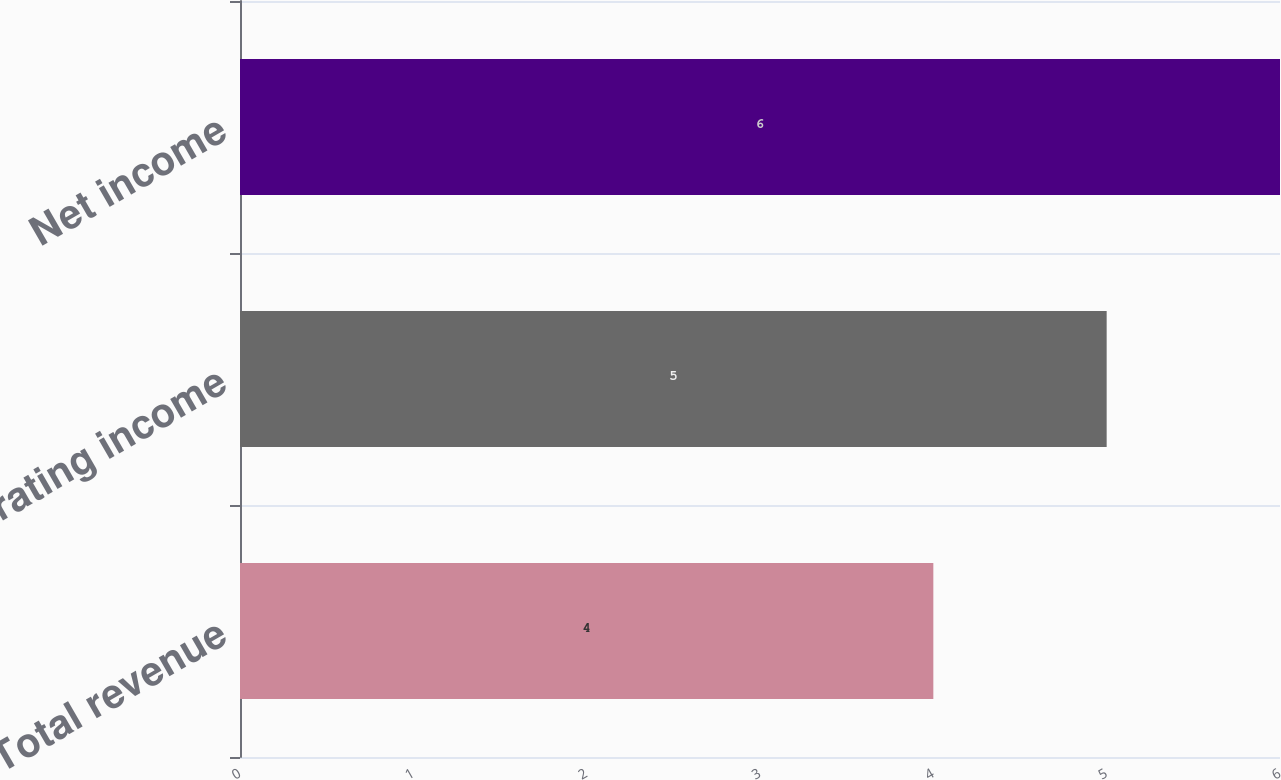Convert chart to OTSL. <chart><loc_0><loc_0><loc_500><loc_500><bar_chart><fcel>Total revenue<fcel>Operating income<fcel>Net income<nl><fcel>4<fcel>5<fcel>6<nl></chart> 